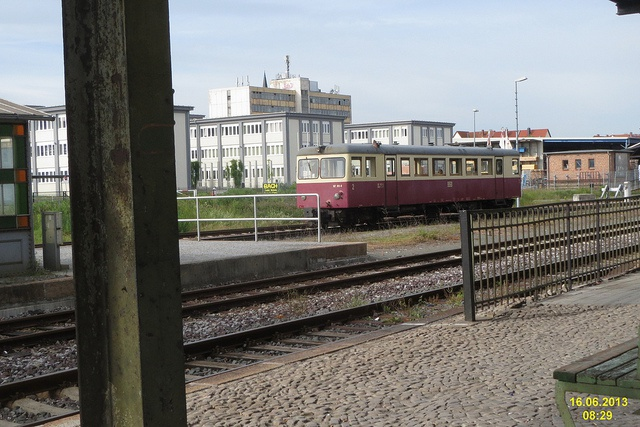Describe the objects in this image and their specific colors. I can see train in lavender, black, gray, and darkgray tones and bench in lavender, gray, darkgreen, and black tones in this image. 